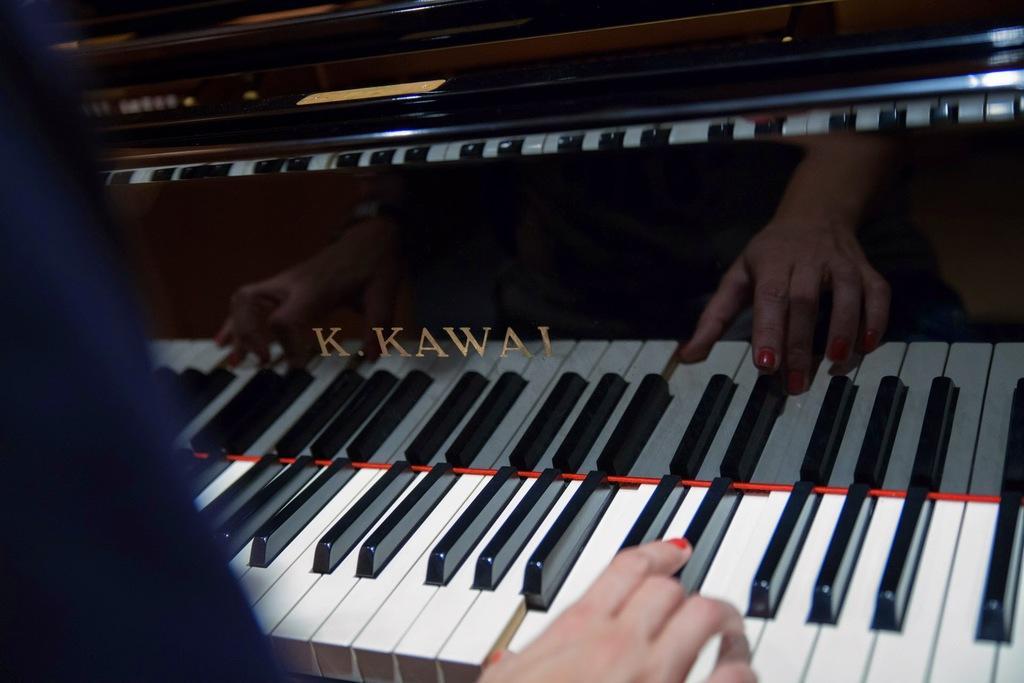Please provide a concise description of this image. In this image on the left side there is one person who is playing a piano, in the middle there is one piano. 